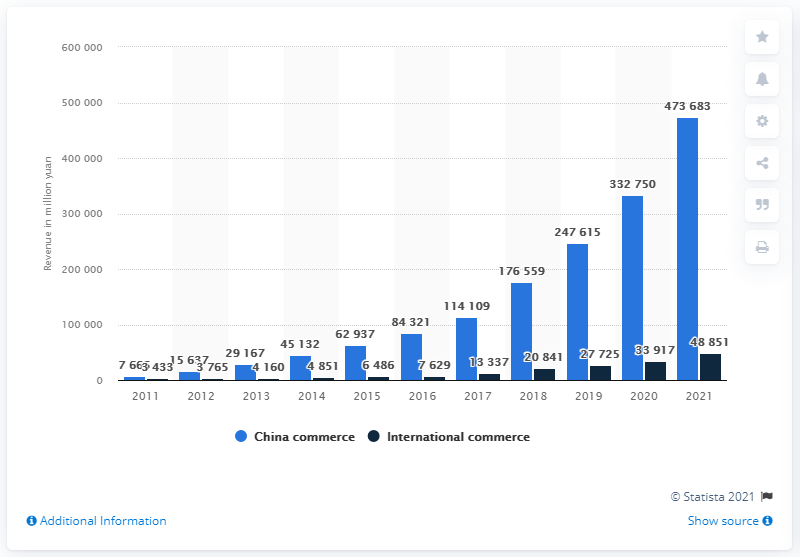Identify some key points in this picture. Alibaba Group's revenue in Chinese online sales was approximately 473,683 in the year 2021. 